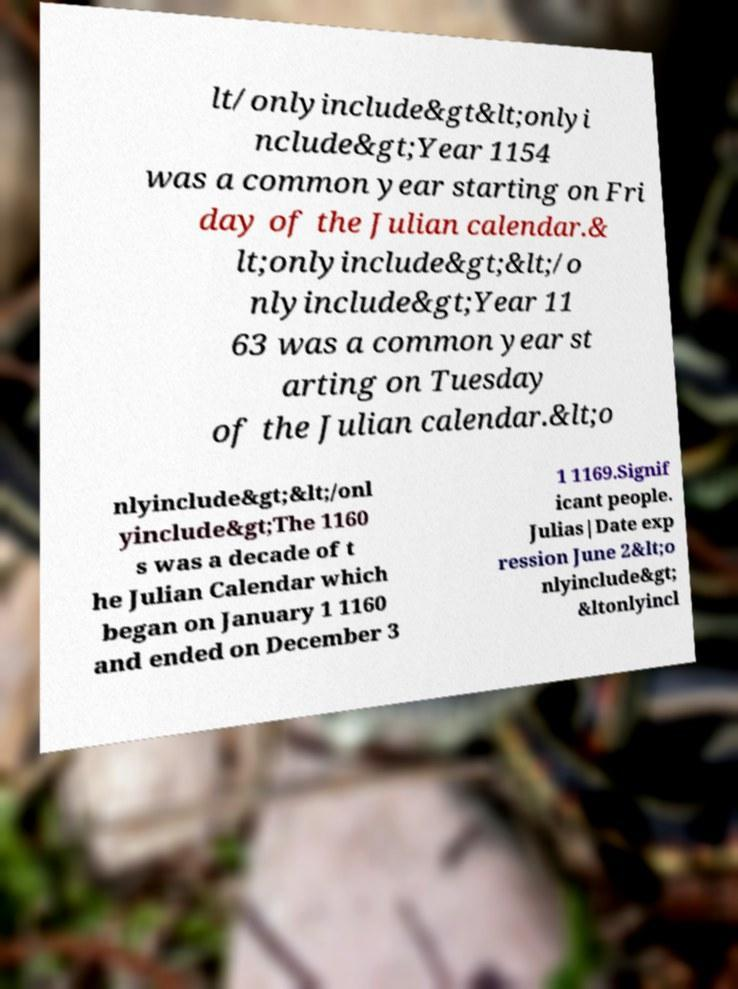Could you assist in decoding the text presented in this image and type it out clearly? lt/onlyinclude&gt&lt;onlyi nclude&gt;Year 1154 was a common year starting on Fri day of the Julian calendar.& lt;onlyinclude&gt;&lt;/o nlyinclude&gt;Year 11 63 was a common year st arting on Tuesday of the Julian calendar.&lt;o nlyinclude&gt;&lt;/onl yinclude&gt;The 1160 s was a decade of t he Julian Calendar which began on January 1 1160 and ended on December 3 1 1169.Signif icant people. Julias|Date exp ression June 2&lt;o nlyinclude&gt; &ltonlyincl 